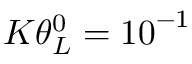Convert formula to latex. <formula><loc_0><loc_0><loc_500><loc_500>K \theta _ { L } ^ { 0 } = { { 1 0 } ^ { - 1 } }</formula> 